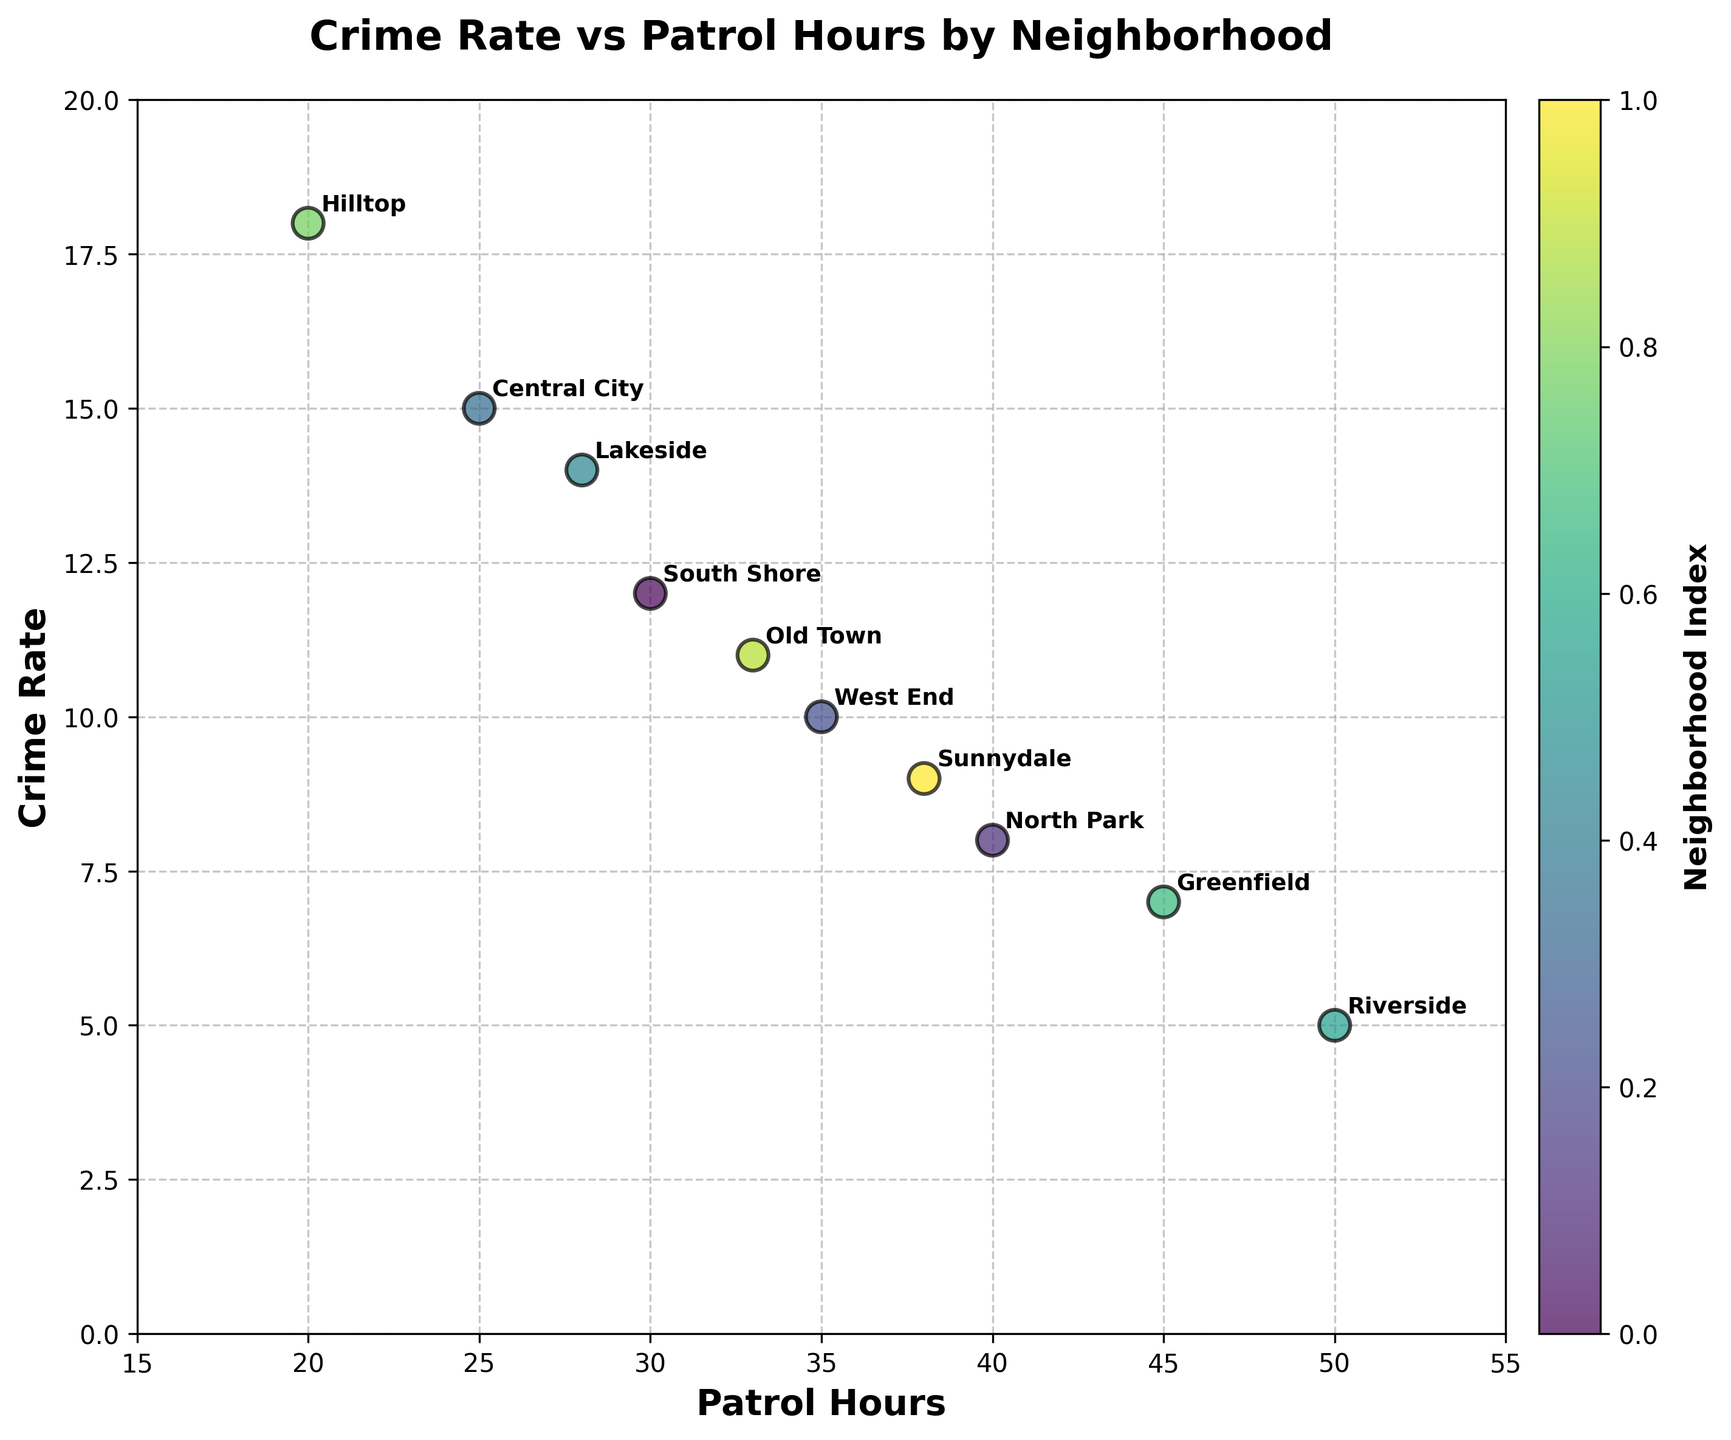How many neighborhoods are represented in the scatter plot? We need to count the number of unique neighborhoods labeled in the scatter plot. Each label represents a different neighborhood.
Answer: 10 What is the title of the scatter plot? The title is usually prominently displayed at the top of the figure.
Answer: Crime Rate vs Patrol Hours by Neighborhood Which neighborhood has the highest crime rate? To determine this, we look for the data point with the highest value on the y-axis (Crime Rate), and check its corresponding label. Hilltop is labeled at the y-value of 18.
Answer: Hilltop Which two neighborhoods have the same crime rate? We need to identify any overlapping y-values in the figure. South Shore and Old Town both have a crime rate of 12.
Answer: South Shore and Old Town What is the crime rate in Central City? Locate the neighborhood label "Central City" and check its corresponding y-value on the scatter plot.
Answer: 15 Which neighborhood has the most patrol hours? The neighborhood with the highest x-value (Patrol Hours) will have the most patrol hours. Riverside is labeled at the x-value of 50.
Answer: Riverside What is the average crime rate of Riverside and Greenfield? Add the crime rates of Riverside (5) and Greenfield (7), then divide by 2 to find the average. (5 + 7) / 2 = 6
Answer: 6 Is there any apparent trend between patrol hours and crime rate? By observing the overall distribution of points, it can be seen if there is a trend. The general trend suggests that as patrol hours increase, the crime rate tends to decrease.
Answer: Crime rate tends to decrease as patrol hours increase How does the crime rate in Lakeside compare to that in North Park? Check the y-values corresponding to both "Lakeside" and "North Park". Lakeside has a y-value of 14, while North Park has 8. Lakeside's crime rate is higher.
Answer: Higher in Lakeside Which neighborhood has the closest crime rate to Sunnydale? First, identify Sunnydale's crime rate (9). Then, check other neighborhoods for the closest y-values. North Park, with a y-value of 8, is the closest.
Answer: North Park 